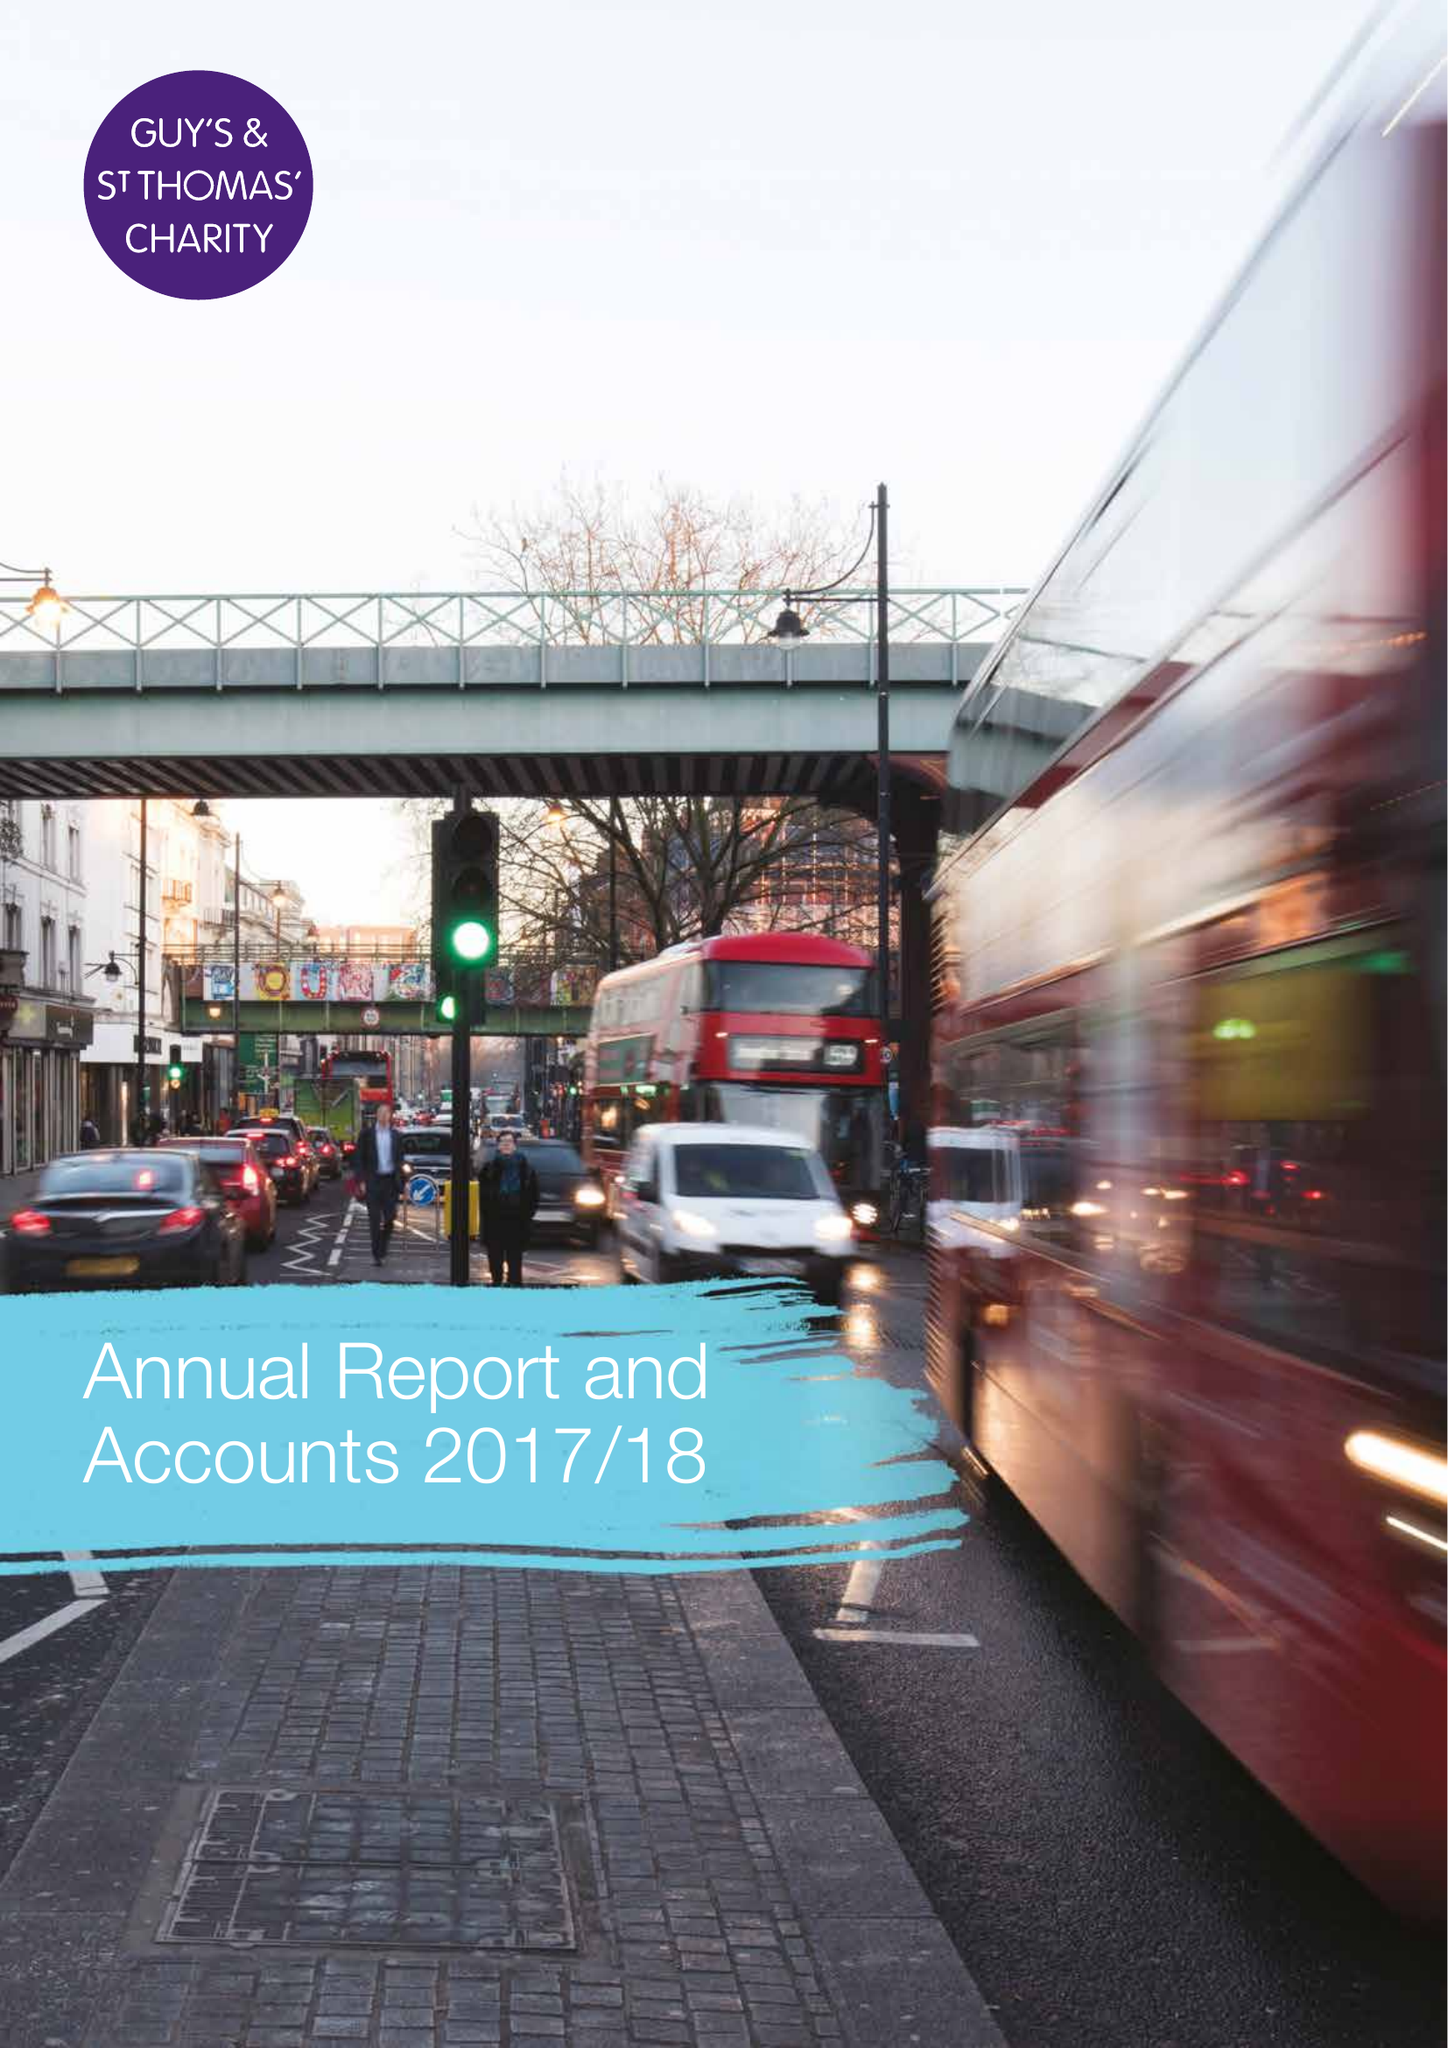What is the value for the charity_name?
Answer the question using a single word or phrase. Guy's and St Thomas' Charity 